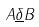Convert formula to latex. <formula><loc_0><loc_0><loc_500><loc_500>A \underline { \delta } B</formula> 